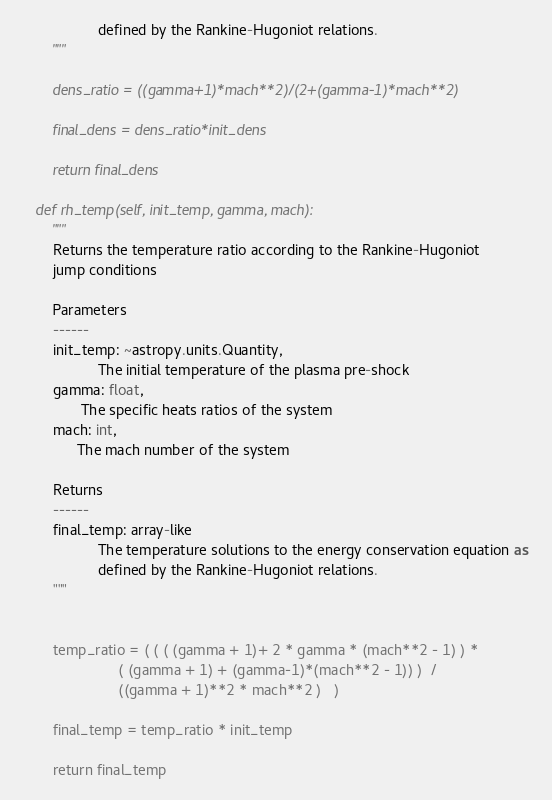Convert code to text. <code><loc_0><loc_0><loc_500><loc_500><_Python_>                   defined by the Rankine-Hugoniot relations.
        """

        dens_ratio = ((gamma+1)*mach**2)/(2+(gamma-1)*mach**2)

        final_dens = dens_ratio*init_dens

        return final_dens 

    def rh_temp(self, init_temp, gamma, mach):
        """
        Returns the temperature ratio according to the Rankine-Hugoniot 
        jump conditions

        Parameters
        ------
        init_temp: ~astropy.units.Quantity,
                   The initial temperature of the plasma pre-shock
        gamma: float,
               The specific heats ratios of the system
        mach: int,
              The mach number of the system

        Returns
        ------
        final_temp: array-like
                   The temperature solutions to the energy conservation equation as 
                   defined by the Rankine-Hugoniot relations.
        """


        temp_ratio = ( ( ( (gamma + 1)+ 2 * gamma * (mach**2 - 1) ) *
                        ( (gamma + 1) + (gamma-1)*(mach**2 - 1)) )  / 
                        ((gamma + 1)**2 * mach**2 )   )

        final_temp = temp_ratio * init_temp
        
        return final_temp</code> 